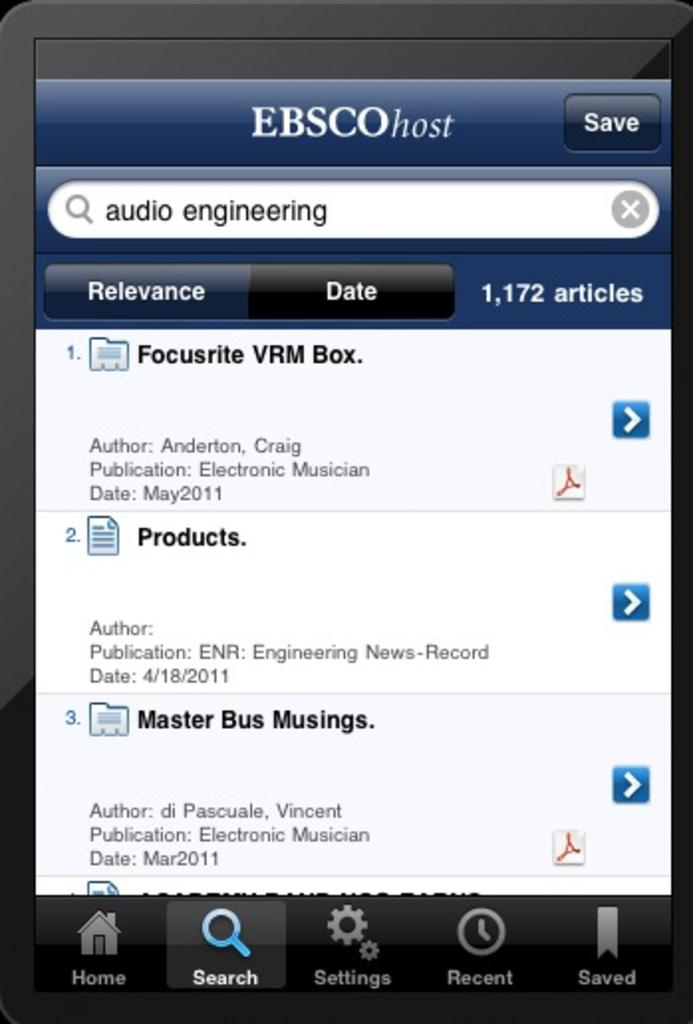<image>
Describe the image concisely. A screen shot shows that there are 1,172 articles relating to audio engineering. 